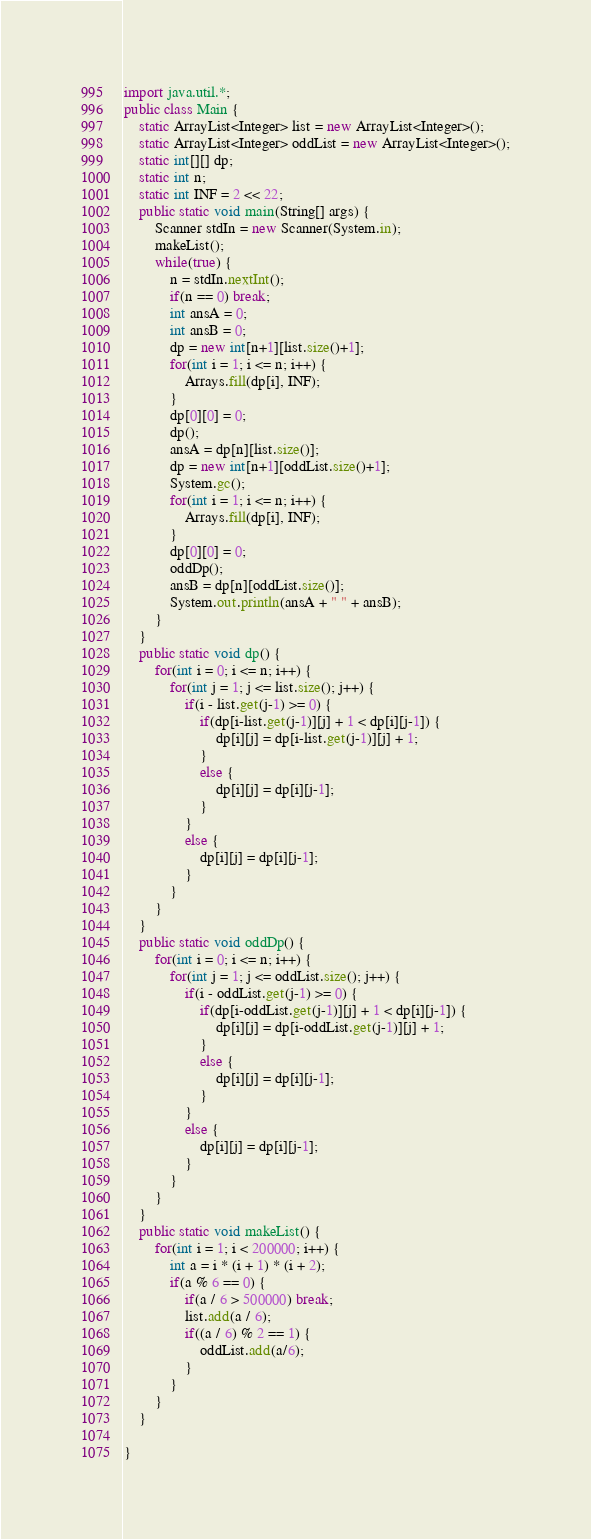<code> <loc_0><loc_0><loc_500><loc_500><_Java_>import java.util.*;
public class Main { 
	static ArrayList<Integer> list = new ArrayList<Integer>();
	static ArrayList<Integer> oddList = new ArrayList<Integer>();
	static int[][] dp;
	static int n;
	static int INF = 2 << 22;
	public static void main(String[] args) {
		Scanner stdIn = new Scanner(System.in);
		makeList();
		while(true) {
			n = stdIn.nextInt();
			if(n == 0) break;
			int ansA = 0;
			int ansB = 0;
			dp = new int[n+1][list.size()+1];
			for(int i = 1; i <= n; i++) {
				Arrays.fill(dp[i], INF);
			}
			dp[0][0] = 0;
			dp();
			ansA = dp[n][list.size()];
			dp = new int[n+1][oddList.size()+1];
			System.gc();
			for(int i = 1; i <= n; i++) {
				Arrays.fill(dp[i], INF);
			}
			dp[0][0] = 0;
			oddDp();
			ansB = dp[n][oddList.size()];
			System.out.println(ansA + " " + ansB);
		}
	}
	public static void dp() {
		for(int i = 0; i <= n; i++) {
			for(int j = 1; j <= list.size(); j++) {
				if(i - list.get(j-1) >= 0) {
					if(dp[i-list.get(j-1)][j] + 1 < dp[i][j-1]) {
						dp[i][j] = dp[i-list.get(j-1)][j] + 1;
					}
					else {
						dp[i][j] = dp[i][j-1];
					}
				}
				else {
					dp[i][j] = dp[i][j-1];
				}
			}
		}
	}
	public static void oddDp() {
		for(int i = 0; i <= n; i++) {
			for(int j = 1; j <= oddList.size(); j++) {
				if(i - oddList.get(j-1) >= 0) {
					if(dp[i-oddList.get(j-1)][j] + 1 < dp[i][j-1]) {
						dp[i][j] = dp[i-oddList.get(j-1)][j] + 1;
					}
					else {
						dp[i][j] = dp[i][j-1];
					}
				}
				else {
					dp[i][j] = dp[i][j-1];
				}
			}
		}
	}
	public static void makeList() {
		for(int i = 1; i < 200000; i++) {
			int a = i * (i + 1) * (i + 2);
			if(a % 6 == 0) {
				if(a / 6 > 500000) break;
				list.add(a / 6);
				if((a / 6) % 2 == 1) {
					oddList.add(a/6);
				}
			}
		}
	}
	
}</code> 